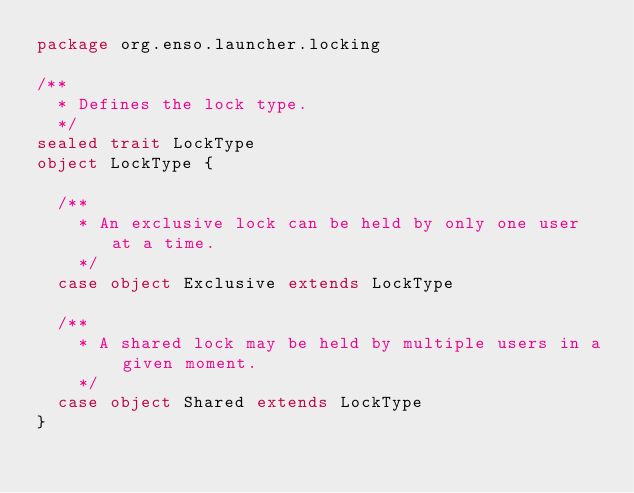Convert code to text. <code><loc_0><loc_0><loc_500><loc_500><_Scala_>package org.enso.launcher.locking

/**
  * Defines the lock type.
  */
sealed trait LockType
object LockType {

  /**
    * An exclusive lock can be held by only one user at a time.
    */
  case object Exclusive extends LockType

  /**
    * A shared lock may be held by multiple users in a given moment.
    */
  case object Shared extends LockType
}
</code> 